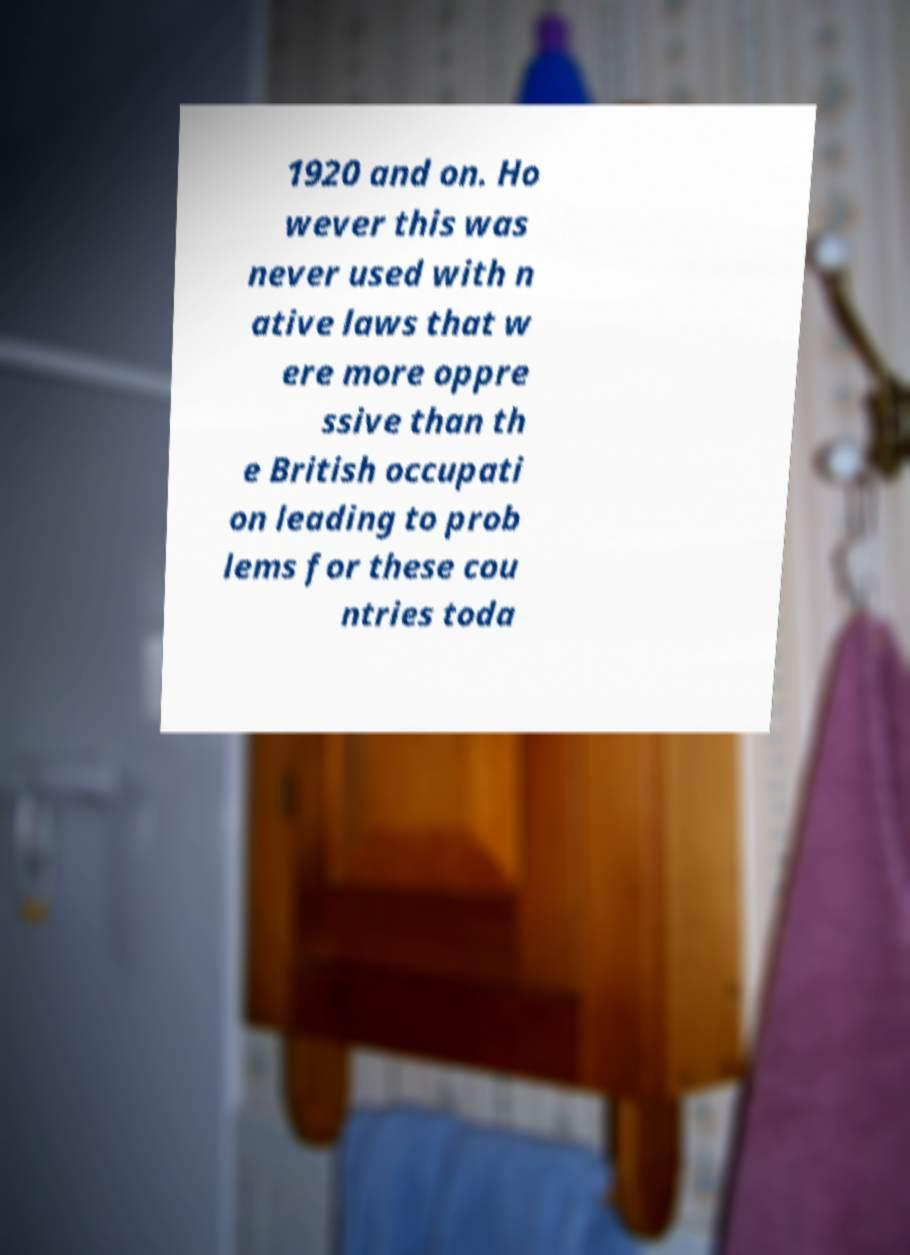Could you assist in decoding the text presented in this image and type it out clearly? 1920 and on. Ho wever this was never used with n ative laws that w ere more oppre ssive than th e British occupati on leading to prob lems for these cou ntries toda 